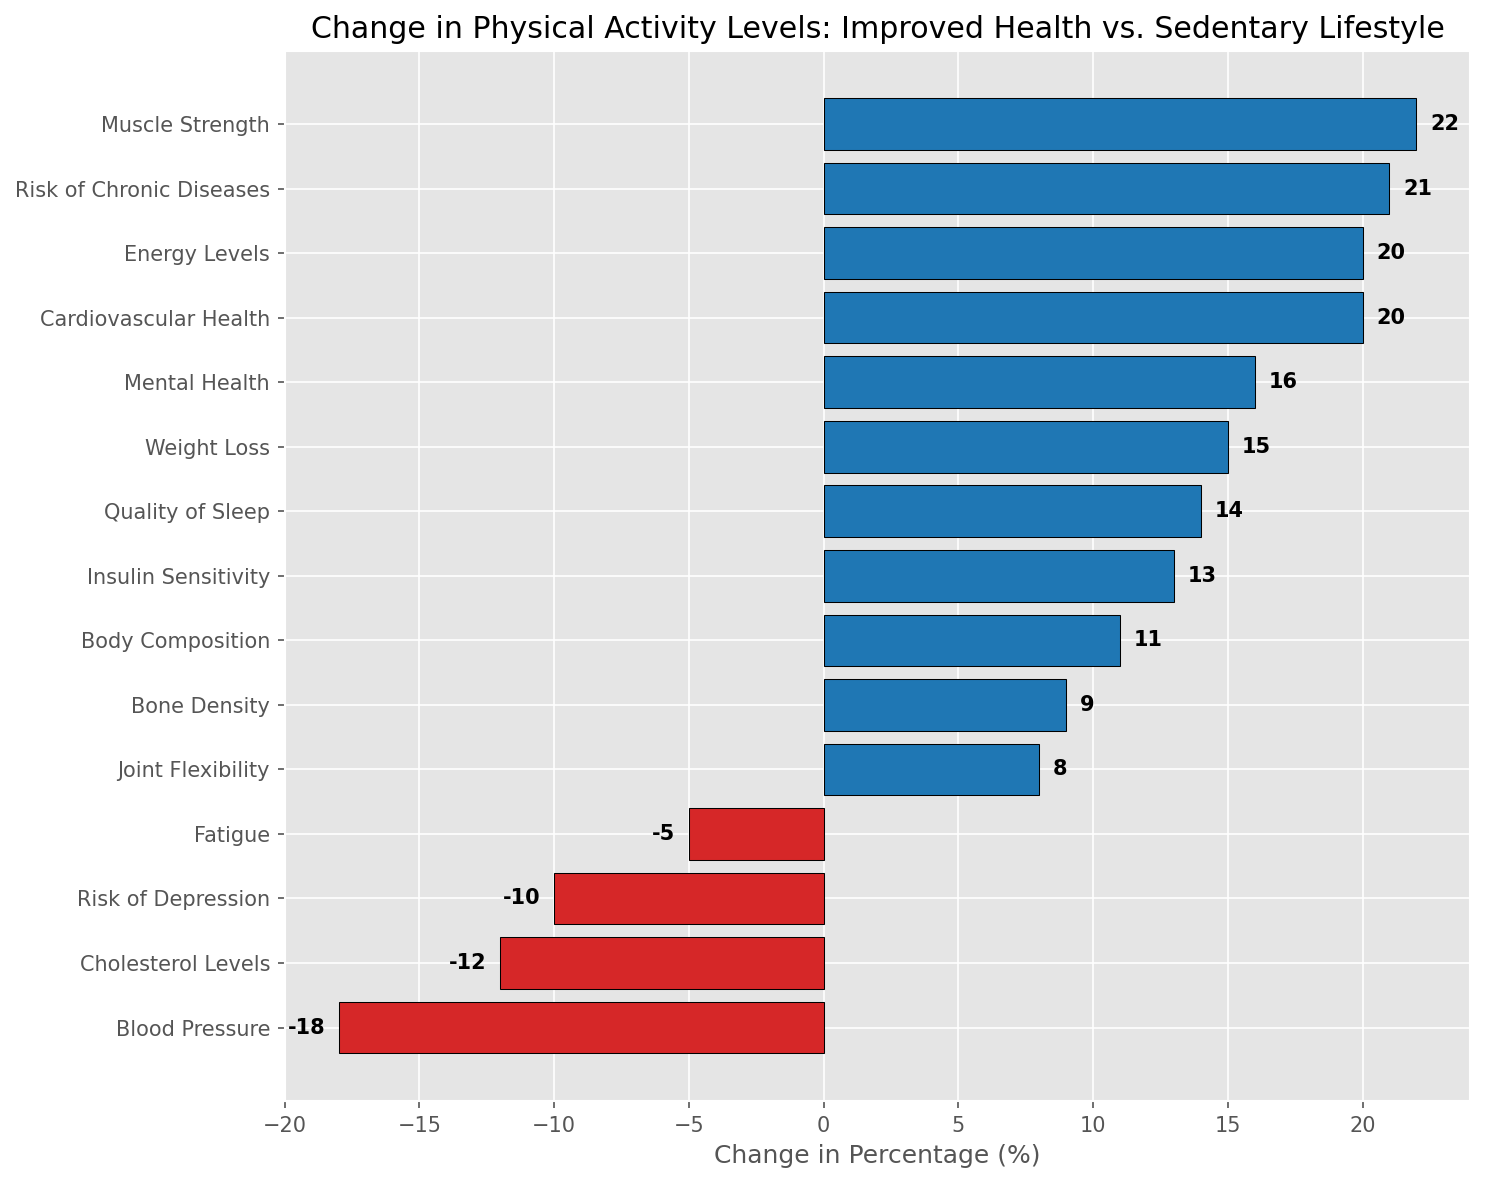What activity has the highest improvement in physical activity levels? The bar chart shows all activities with their associated changes in percentage. The tallest blue bar represents the activity with the highest improvement.
Answer: Muscle Strength Which activity experienced the largest decline due to a sedentary lifestyle? The longest red bar in the chart represents the activity with the biggest negative change.
Answer: Blood Pressure What is the difference in percentage change between Cardiovascular Health and Blood Pressure? Cardiovascular Health has a change of 20% and Blood Pressure has a change of -18%. The difference is 20 - (-18) = 38.
Answer: 38 Which activities have a positive change in physical activity levels but below 10%? The blue bars that are less than 10% represent these activities, which include Bone Density and Joint Flexibility.
Answer: Bone Density, Joint Flexibility How many activities show improved health compared to those showing decline due to a sedentary lifestyle? Count the number of blue bars (positive changes) and the number of red bars (negative changes) in the chart. There are 11 activities with positive change and 4 activities with negative change.
Answer: 11 improved, 4 declined What is the total positive improvement in percentage for all activities listed? Sum the changes in percentage for all activities with positive values: 15 + 20 + 13 + 22 + 9 + 16 + 14 + 20 + 21 + 8 + 11 = 169.
Answer: 169% Which activity shows a similar improvement to that of Insulin Sensitivity? Insulin Sensitivity has a change of 13%. Quality of Sleep, which has a change of 14%, is closest to this value.
Answer: Quality of Sleep What is the average percentage change for activities related to mental health, i.e., Mental Health and Risk of Depression? For Mental Health (16%) and Risk of Depression (-10%), the average is (16 + (-10))/2 = 6/2 = 3%.
Answer: 3% Between Muscular Strength and Body Composition, which demonstrates a higher improvement and by how much? Muscle Strength has a change of 22% and Body Composition has a change of 11%. The difference is 22 - 11 = 11%.
Answer: Muscle Strength by 11% If you were to combine the improvements in Cardiovascular Health and Energy Levels, what would be the total percentage increase? Cardiovascular Health has 20% and Energy Levels also have 20%. Combined, it's 20 + 20 = 40%.
Answer: 40% 